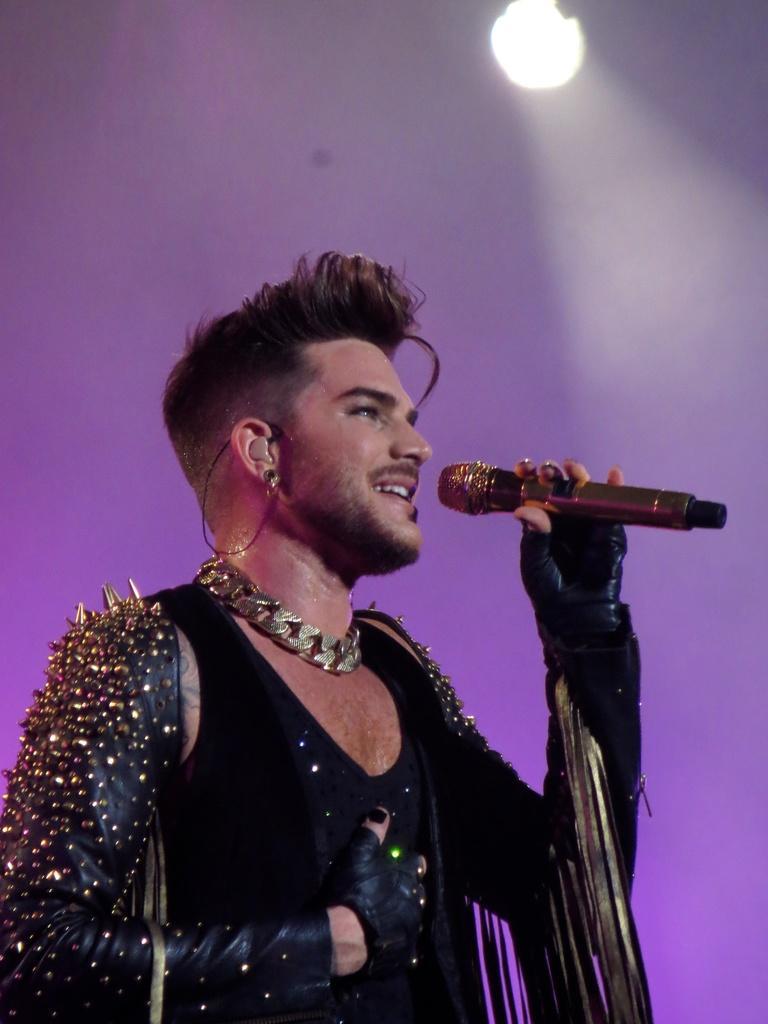Describe this image in one or two sentences. In the image there is a man with black vest and jewellery holding a mic, hr seems to be a pop star, over the top there is a light and the background is in purple color. 